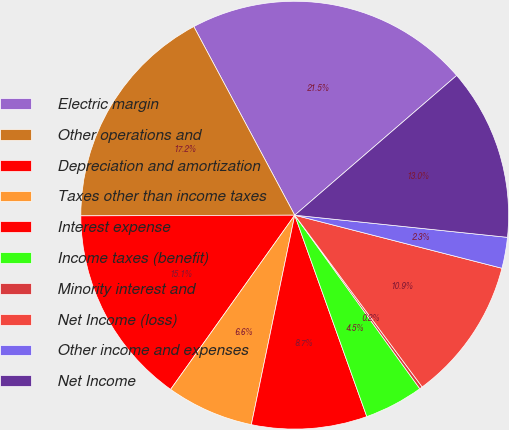Convert chart. <chart><loc_0><loc_0><loc_500><loc_500><pie_chart><fcel>Electric margin<fcel>Other operations and<fcel>Depreciation and amortization<fcel>Taxes other than income taxes<fcel>Interest expense<fcel>Income taxes (benefit)<fcel>Minority interest and<fcel>Net Income (loss)<fcel>Other income and expenses<fcel>Net Income<nl><fcel>21.49%<fcel>17.23%<fcel>15.1%<fcel>6.6%<fcel>8.72%<fcel>4.47%<fcel>0.22%<fcel>10.85%<fcel>2.34%<fcel>12.98%<nl></chart> 